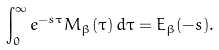Convert formula to latex. <formula><loc_0><loc_0><loc_500><loc_500>\int _ { 0 } ^ { \infty } e ^ { - s \tau } M _ { \beta } ( \tau ) \, d \tau = E _ { \beta } ( - s ) .</formula> 